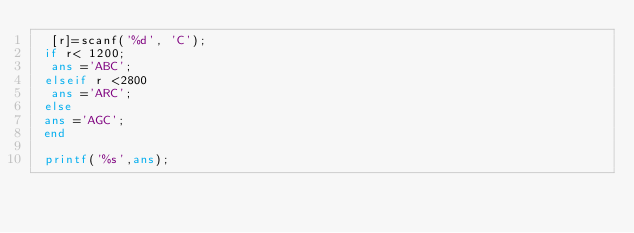<code> <loc_0><loc_0><loc_500><loc_500><_Octave_>  [r]=scanf('%d', 'C');
 if r< 1200;
  ans ='ABC';
 elseif r <2800
  ans ='ARC';
 else
 ans ='AGC';
 end

 printf('%s',ans);
</code> 